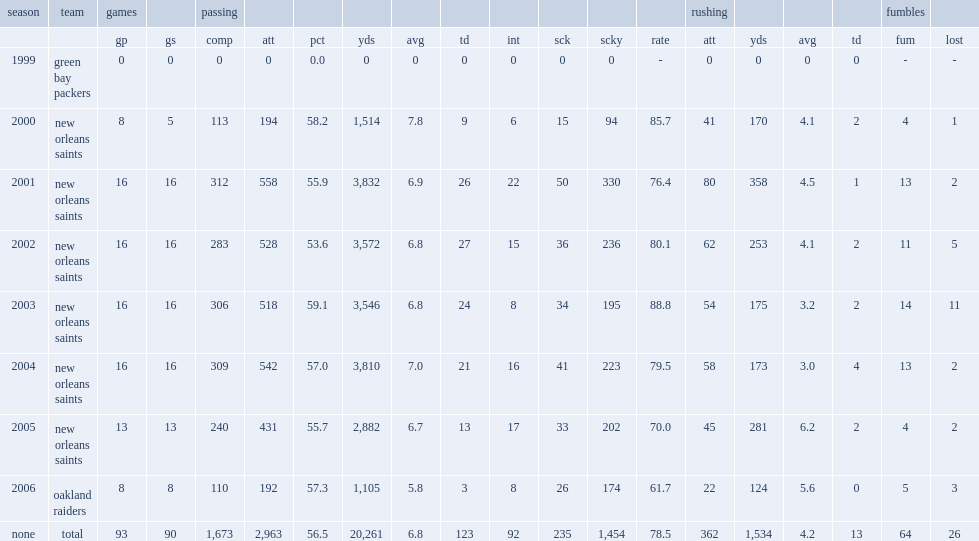Give me the full table as a dictionary. {'header': ['season', 'team', 'games', '', 'passing', '', '', '', '', '', '', '', '', '', 'rushing', '', '', '', 'fumbles', ''], 'rows': [['', '', 'gp', 'gs', 'comp', 'att', 'pct', 'yds', 'avg', 'td', 'int', 'sck', 'scky', 'rate', 'att', 'yds', 'avg', 'td', 'fum', 'lost'], ['1999', 'green bay packers', '0', '0', '0', '0', '0.0', '0', '0', '0', '0', '0', '0', '-', '0', '0', '0', '0', '-', '-'], ['2000', 'new orleans saints', '8', '5', '113', '194', '58.2', '1,514', '7.8', '9', '6', '15', '94', '85.7', '41', '170', '4.1', '2', '4', '1'], ['2001', 'new orleans saints', '16', '16', '312', '558', '55.9', '3,832', '6.9', '26', '22', '50', '330', '76.4', '80', '358', '4.5', '1', '13', '2'], ['2002', 'new orleans saints', '16', '16', '283', '528', '53.6', '3,572', '6.8', '27', '15', '36', '236', '80.1', '62', '253', '4.1', '2', '11', '5'], ['2003', 'new orleans saints', '16', '16', '306', '518', '59.1', '3,546', '6.8', '24', '8', '34', '195', '88.8', '54', '175', '3.2', '2', '14', '11'], ['2004', 'new orleans saints', '16', '16', '309', '542', '57.0', '3,810', '7.0', '21', '16', '41', '223', '79.5', '58', '173', '3.0', '4', '13', '2'], ['2005', 'new orleans saints', '13', '13', '240', '431', '55.7', '2,882', '6.7', '13', '17', '33', '202', '70.0', '45', '281', '6.2', '2', '4', '2'], ['2006', 'oakland raiders', '8', '8', '110', '192', '57.3', '1,105', '5.8', '3', '8', '26', '174', '61.7', '22', '124', '5.6', '0', '5', '3'], ['none', 'total', '93', '90', '1,673', '2,963', '56.5', '20,261', '6.8', '123', '92', '235', '1,454', '78.5', '362', '1,534', '4.2', '13', '64', '26']]} In 2003, what is the touchdown to interception ratio for brooks? 3. 